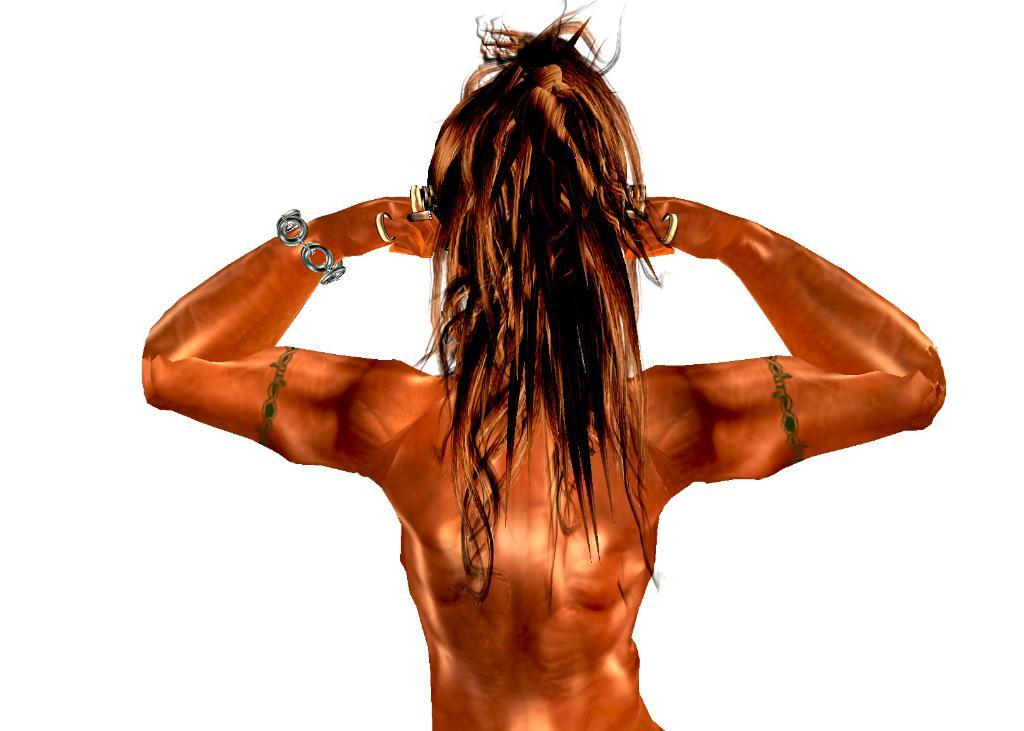What is the main subject of the image? There is an animated picture of a person in the image. Where is the animated picture located in the image? The animated picture is in the center of the image. What type of birthday celebration is depicted in the image? There is no birthday celebration depicted in the image; it features an animated picture of a person in the center. Can you see a monkey playing volleyball in the image? There is no monkey or volleyball present in the image. 